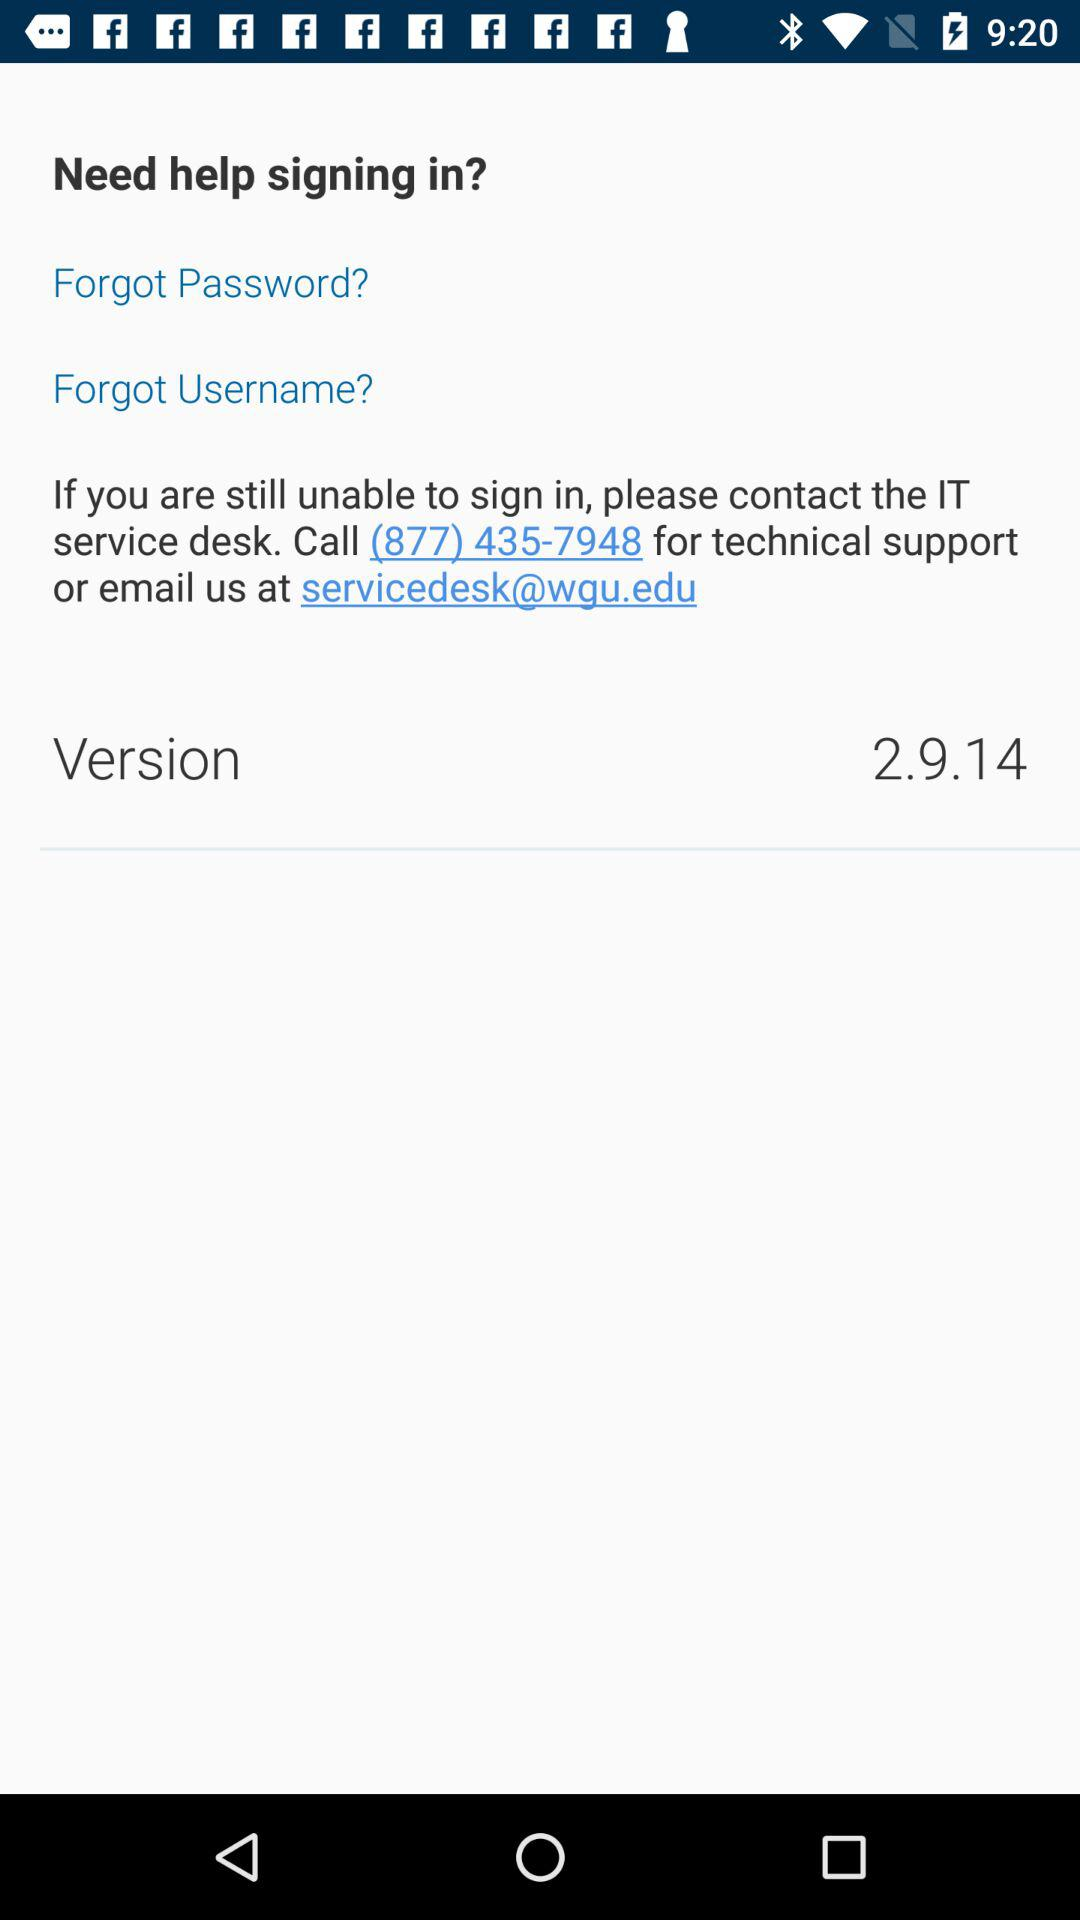Which version is used? The used version is 2.9.14. 